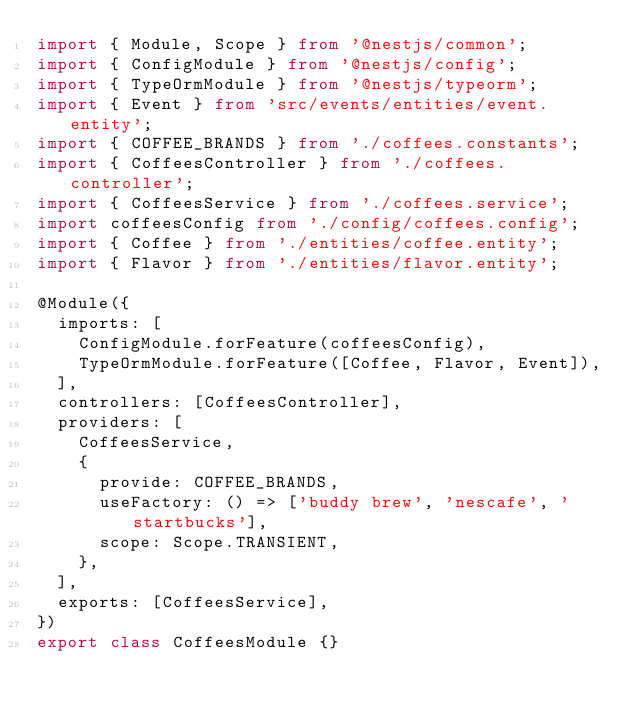<code> <loc_0><loc_0><loc_500><loc_500><_TypeScript_>import { Module, Scope } from '@nestjs/common';
import { ConfigModule } from '@nestjs/config';
import { TypeOrmModule } from '@nestjs/typeorm';
import { Event } from 'src/events/entities/event.entity';
import { COFFEE_BRANDS } from './coffees.constants';
import { CoffeesController } from './coffees.controller';
import { CoffeesService } from './coffees.service';
import coffeesConfig from './config/coffees.config';
import { Coffee } from './entities/coffee.entity';
import { Flavor } from './entities/flavor.entity';

@Module({
  imports: [
    ConfigModule.forFeature(coffeesConfig),
    TypeOrmModule.forFeature([Coffee, Flavor, Event]),
  ],
  controllers: [CoffeesController],
  providers: [
    CoffeesService,
    {
      provide: COFFEE_BRANDS,
      useFactory: () => ['buddy brew', 'nescafe', 'startbucks'],
      scope: Scope.TRANSIENT,
    },
  ],
  exports: [CoffeesService],
})
export class CoffeesModule {}
</code> 